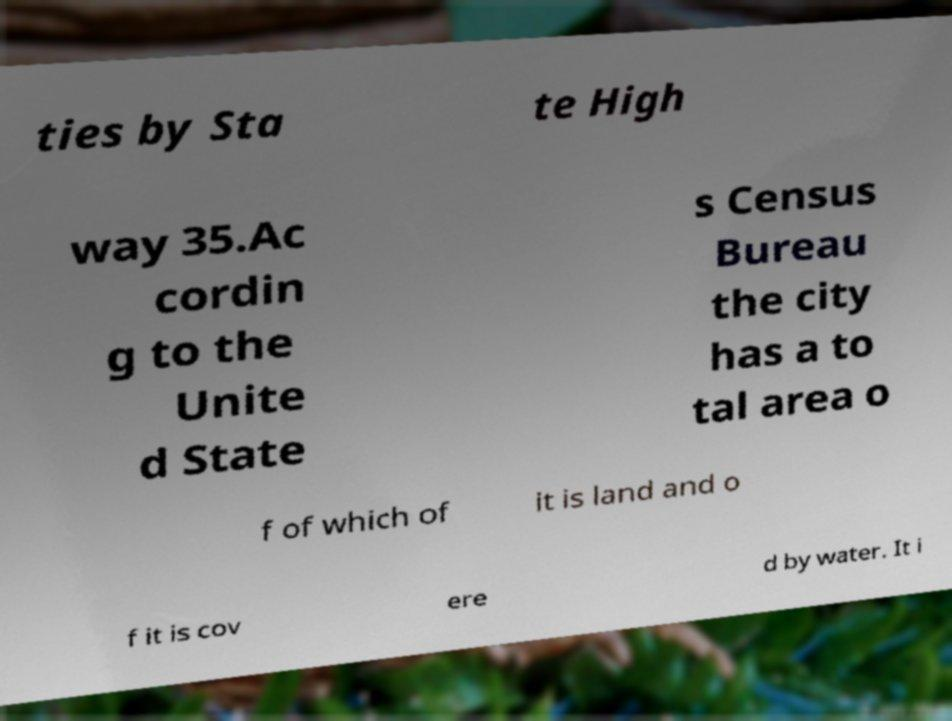Please read and relay the text visible in this image. What does it say? ties by Sta te High way 35.Ac cordin g to the Unite d State s Census Bureau the city has a to tal area o f of which of it is land and o f it is cov ere d by water. It i 